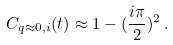Convert formula to latex. <formula><loc_0><loc_0><loc_500><loc_500>C _ { q \approx 0 , i } ( t ) \approx 1 - ( \frac { i \pi } { 2 } ) ^ { 2 } \, .</formula> 